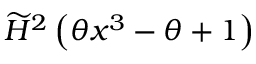<formula> <loc_0><loc_0><loc_500><loc_500>\widetilde { H } ^ { 2 } \left ( \theta x ^ { 3 } - \theta + 1 \right )</formula> 